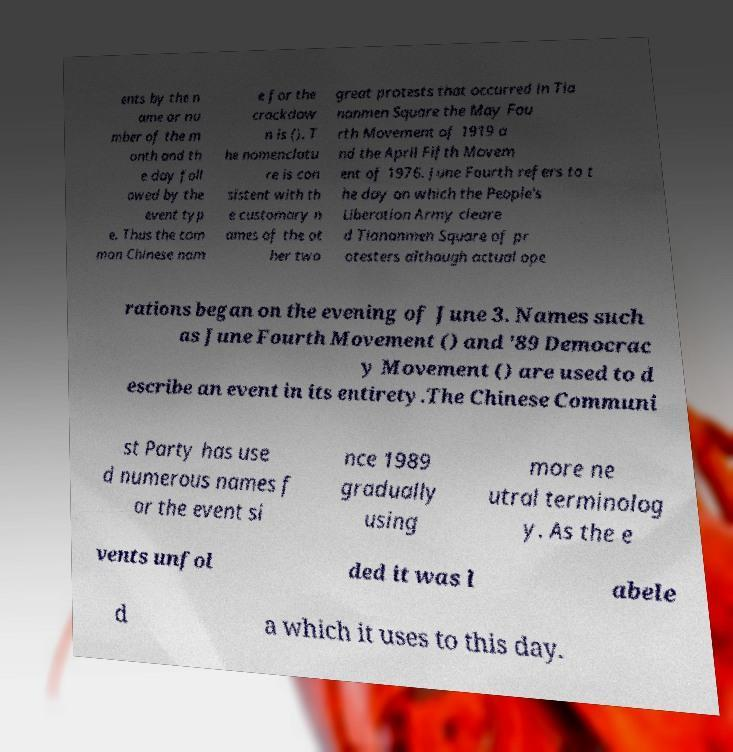I need the written content from this picture converted into text. Can you do that? ents by the n ame or nu mber of the m onth and th e day foll owed by the event typ e. Thus the com mon Chinese nam e for the crackdow n is (). T he nomenclatu re is con sistent with th e customary n ames of the ot her two great protests that occurred in Tia nanmen Square the May Fou rth Movement of 1919 a nd the April Fifth Movem ent of 1976. June Fourth refers to t he day on which the People's Liberation Army cleare d Tiananmen Square of pr otesters although actual ope rations began on the evening of June 3. Names such as June Fourth Movement () and '89 Democrac y Movement () are used to d escribe an event in its entirety.The Chinese Communi st Party has use d numerous names f or the event si nce 1989 gradually using more ne utral terminolog y. As the e vents unfol ded it was l abele d a which it uses to this day. 